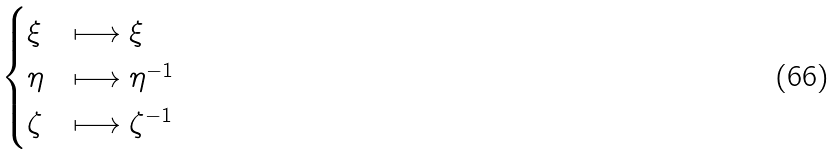Convert formula to latex. <formula><loc_0><loc_0><loc_500><loc_500>\begin{cases} \xi & \longmapsto \xi \\ \eta & \longmapsto \eta ^ { - 1 } \\ \zeta & \longmapsto \zeta ^ { - 1 } \end{cases}</formula> 